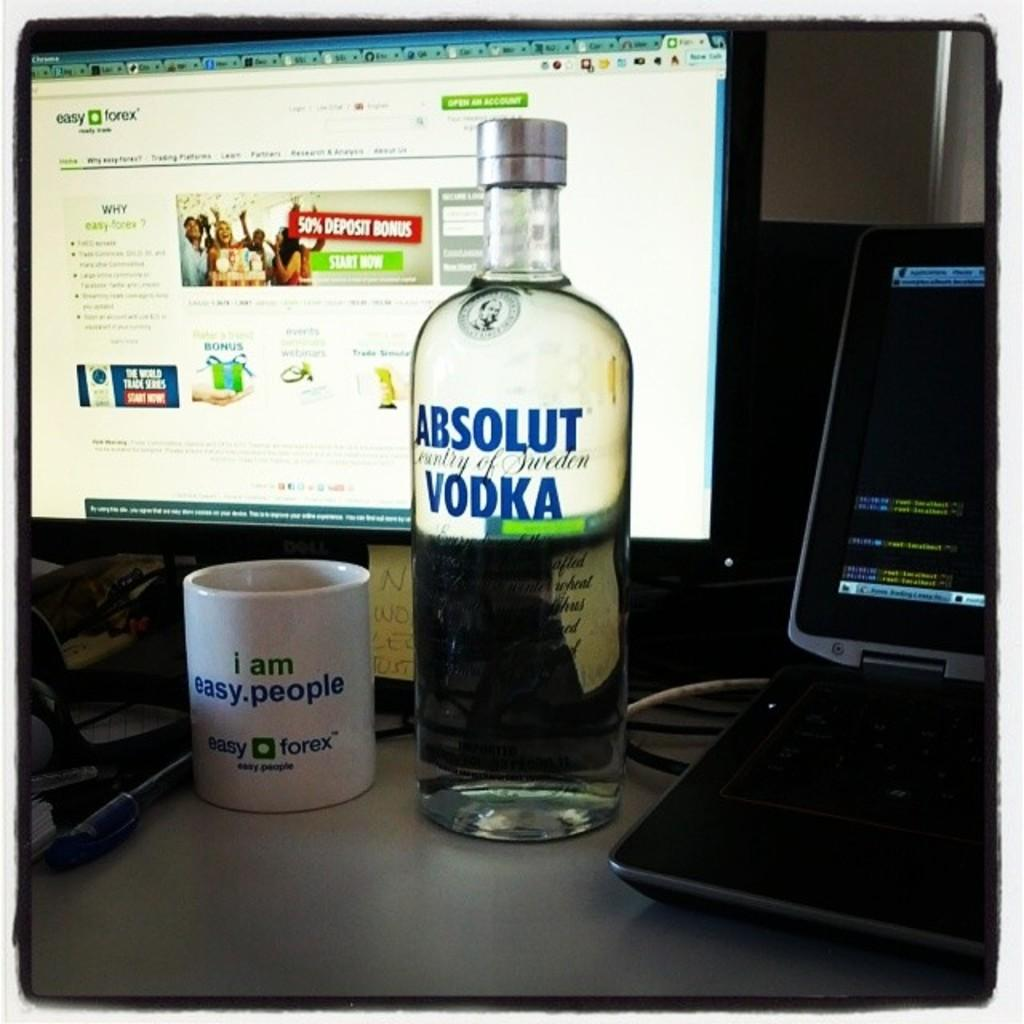<image>
Provide a brief description of the given image. a vodka bottle that says Absolut Vodka on it 